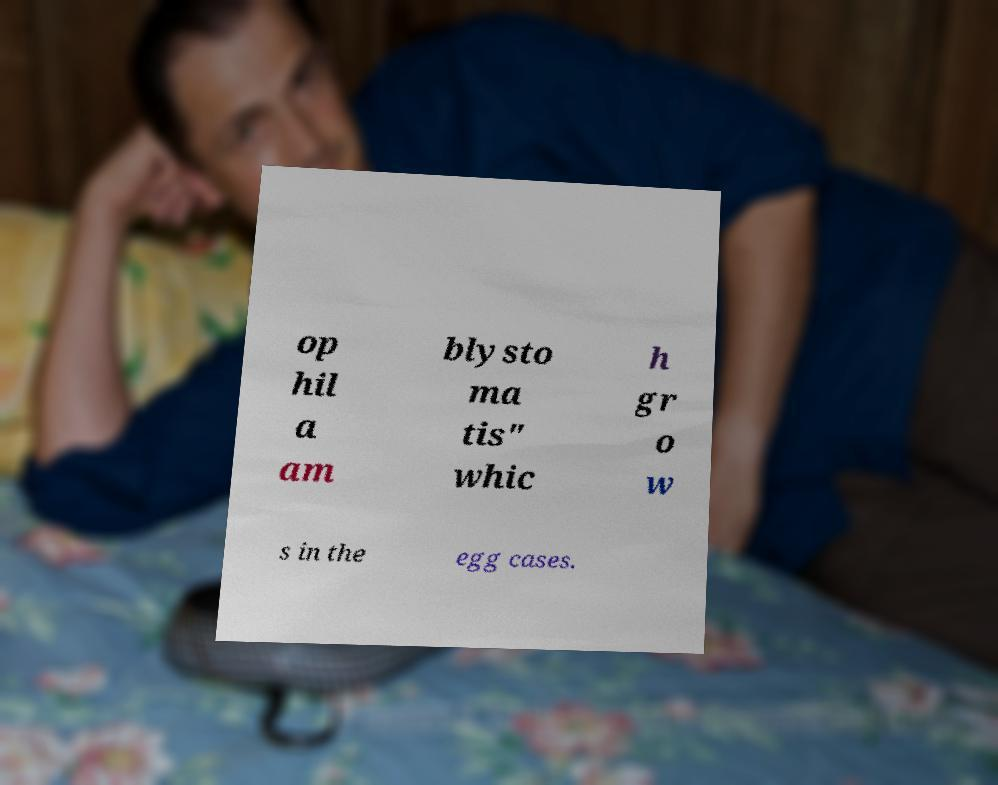For documentation purposes, I need the text within this image transcribed. Could you provide that? op hil a am blysto ma tis" whic h gr o w s in the egg cases. 